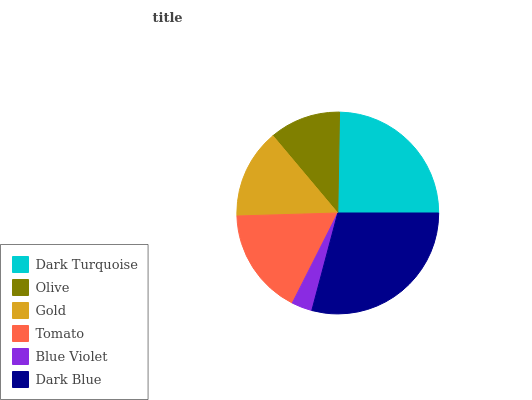Is Blue Violet the minimum?
Answer yes or no. Yes. Is Dark Blue the maximum?
Answer yes or no. Yes. Is Olive the minimum?
Answer yes or no. No. Is Olive the maximum?
Answer yes or no. No. Is Dark Turquoise greater than Olive?
Answer yes or no. Yes. Is Olive less than Dark Turquoise?
Answer yes or no. Yes. Is Olive greater than Dark Turquoise?
Answer yes or no. No. Is Dark Turquoise less than Olive?
Answer yes or no. No. Is Tomato the high median?
Answer yes or no. Yes. Is Gold the low median?
Answer yes or no. Yes. Is Blue Violet the high median?
Answer yes or no. No. Is Olive the low median?
Answer yes or no. No. 